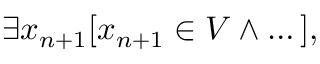<formula> <loc_0><loc_0><loc_500><loc_500>\exists x _ { n + 1 } [ x _ { n + 1 } \in V \land \dots ] ,</formula> 